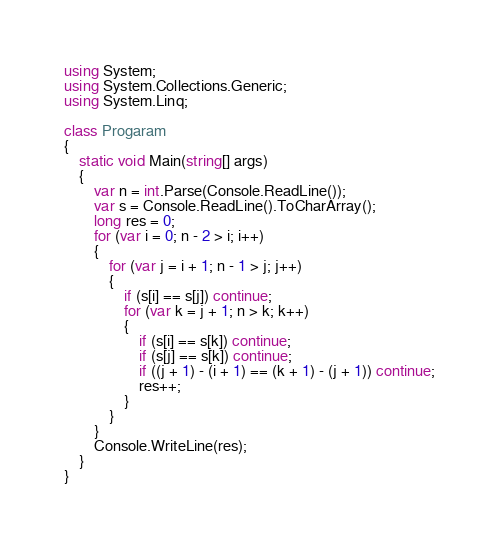Convert code to text. <code><loc_0><loc_0><loc_500><loc_500><_C#_>using System;
using System.Collections.Generic;
using System.Linq;

class Progaram
{
    static void Main(string[] args)
    {
        var n = int.Parse(Console.ReadLine());
        var s = Console.ReadLine().ToCharArray();
        long res = 0;
        for (var i = 0; n - 2 > i; i++)
        {
            for (var j = i + 1; n - 1 > j; j++)
            {
                if (s[i] == s[j]) continue;
                for (var k = j + 1; n > k; k++)
                {
                    if (s[i] == s[k]) continue;
                    if (s[j] == s[k]) continue;
                    if ((j + 1) - (i + 1) == (k + 1) - (j + 1)) continue;
                    res++;
                }
            }
        }
        Console.WriteLine(res);
    }
}
</code> 